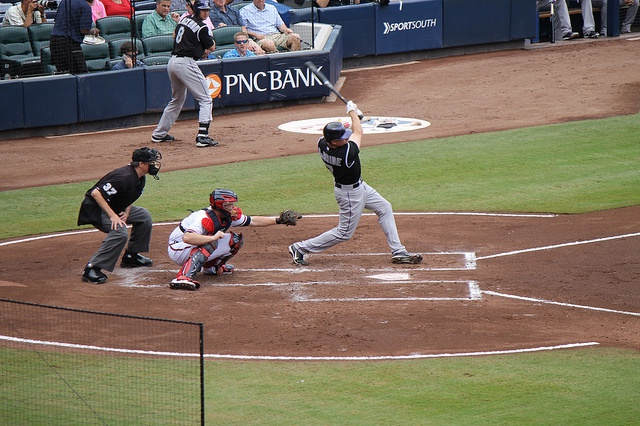Describe the objects in this image and their specific colors. I can see people in black, gray, and tan tones, people in black, darkgray, lavender, and gray tones, people in black, lavender, gray, and maroon tones, people in black, darkgray, gray, and lavender tones, and people in black, navy, darkblue, and gray tones in this image. 